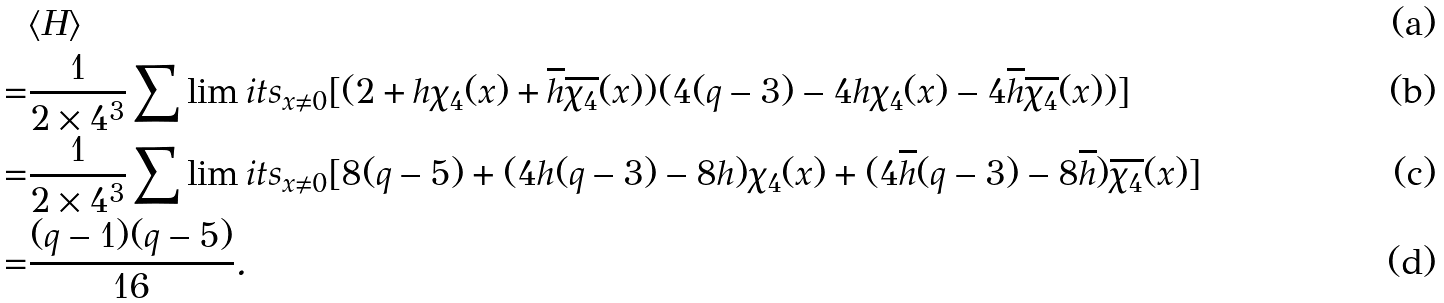<formula> <loc_0><loc_0><loc_500><loc_500>& \langle H \rangle \\ = & \frac { 1 } { 2 \times 4 ^ { 3 } } \sum \lim i t s _ { x \neq 0 } [ ( 2 + h \chi _ { 4 } ( x ) + \overline { h } \overline { \chi _ { 4 } } ( x ) ) ( 4 ( q - 3 ) - 4 h \chi _ { 4 } ( x ) - 4 \overline { h } \overline { \chi _ { 4 } } ( x ) ) ] \\ = & \frac { 1 } { 2 \times 4 ^ { 3 } } \sum \lim i t s _ { x \neq 0 } [ 8 ( q - 5 ) + ( 4 h ( q - 3 ) - 8 h ) \chi _ { 4 } ( x ) + ( 4 \overline { h } ( q - 3 ) - 8 \overline { h } ) \overline { \chi _ { 4 } } ( x ) ] \\ = & \frac { ( q - 1 ) ( q - 5 ) } { 1 6 } .</formula> 